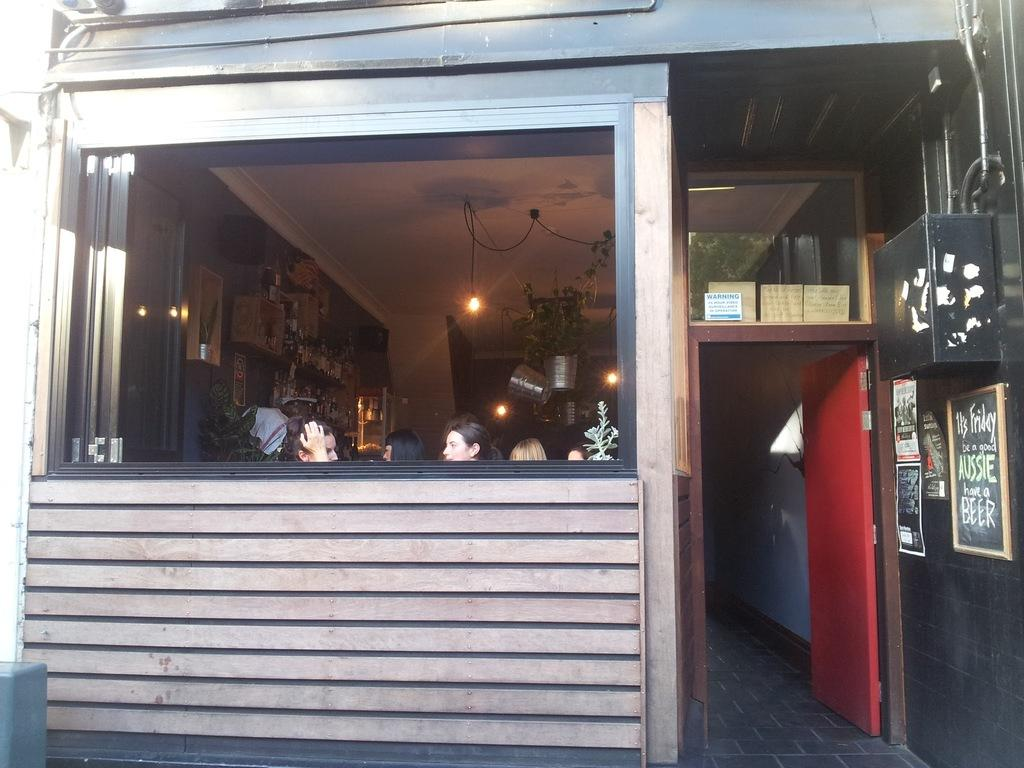Who or what is present in the image? There are people in the image. Where is the door located in the image? The door is on the right side of the image. What is written or displayed on the board in the image? There is a board with text in the image. Can you describe the lighting in the image? There is a light hanging on the wall in the background of the image. What type of prose is being recited by the people in the image? There is no indication in the image that the people are reciting any prose. 